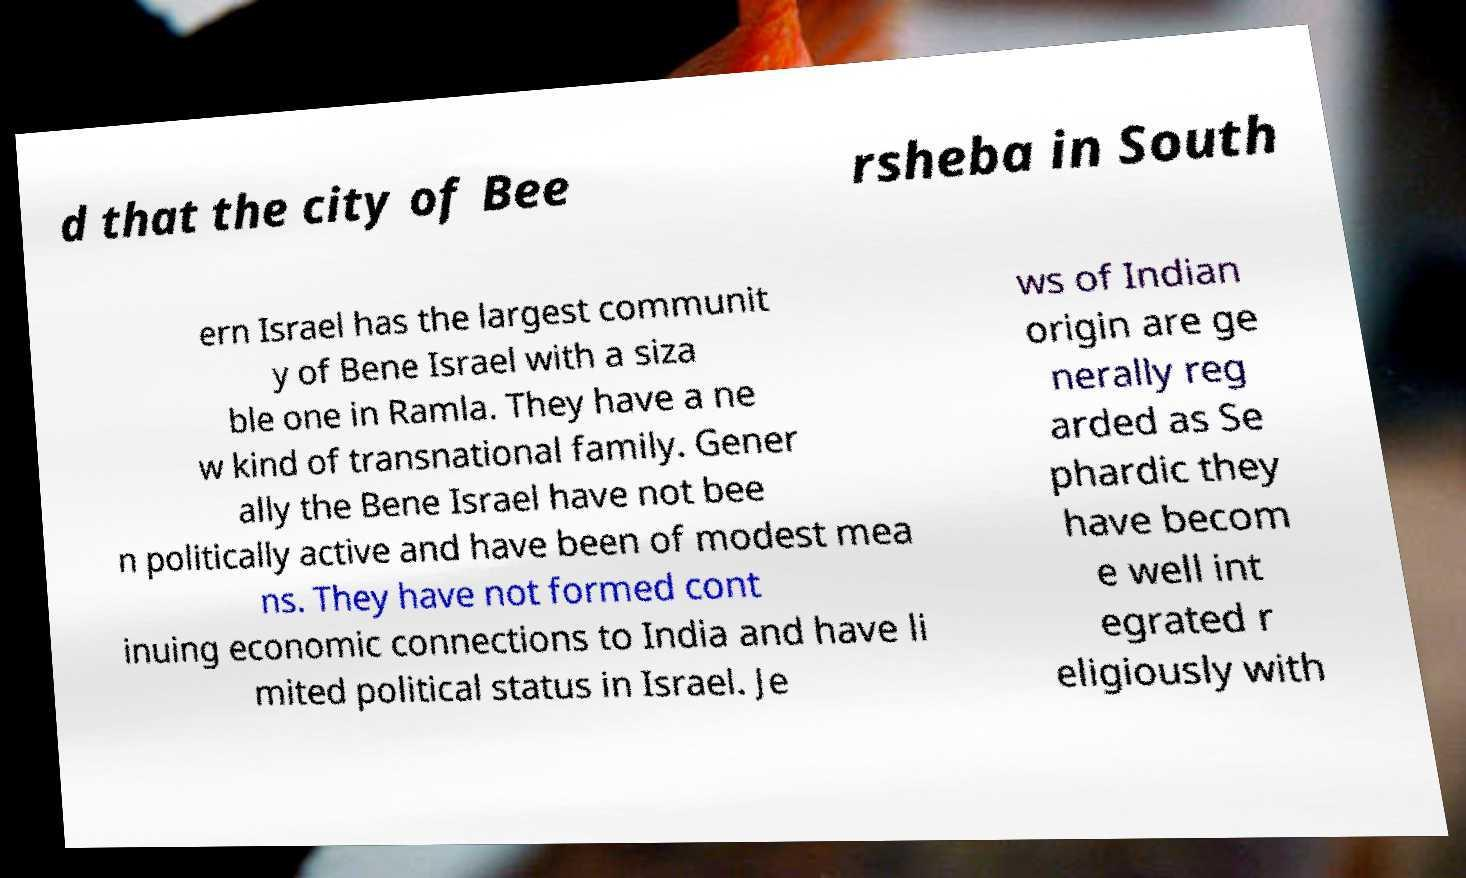Could you assist in decoding the text presented in this image and type it out clearly? d that the city of Bee rsheba in South ern Israel has the largest communit y of Bene Israel with a siza ble one in Ramla. They have a ne w kind of transnational family. Gener ally the Bene Israel have not bee n politically active and have been of modest mea ns. They have not formed cont inuing economic connections to India and have li mited political status in Israel. Je ws of Indian origin are ge nerally reg arded as Se phardic they have becom e well int egrated r eligiously with 